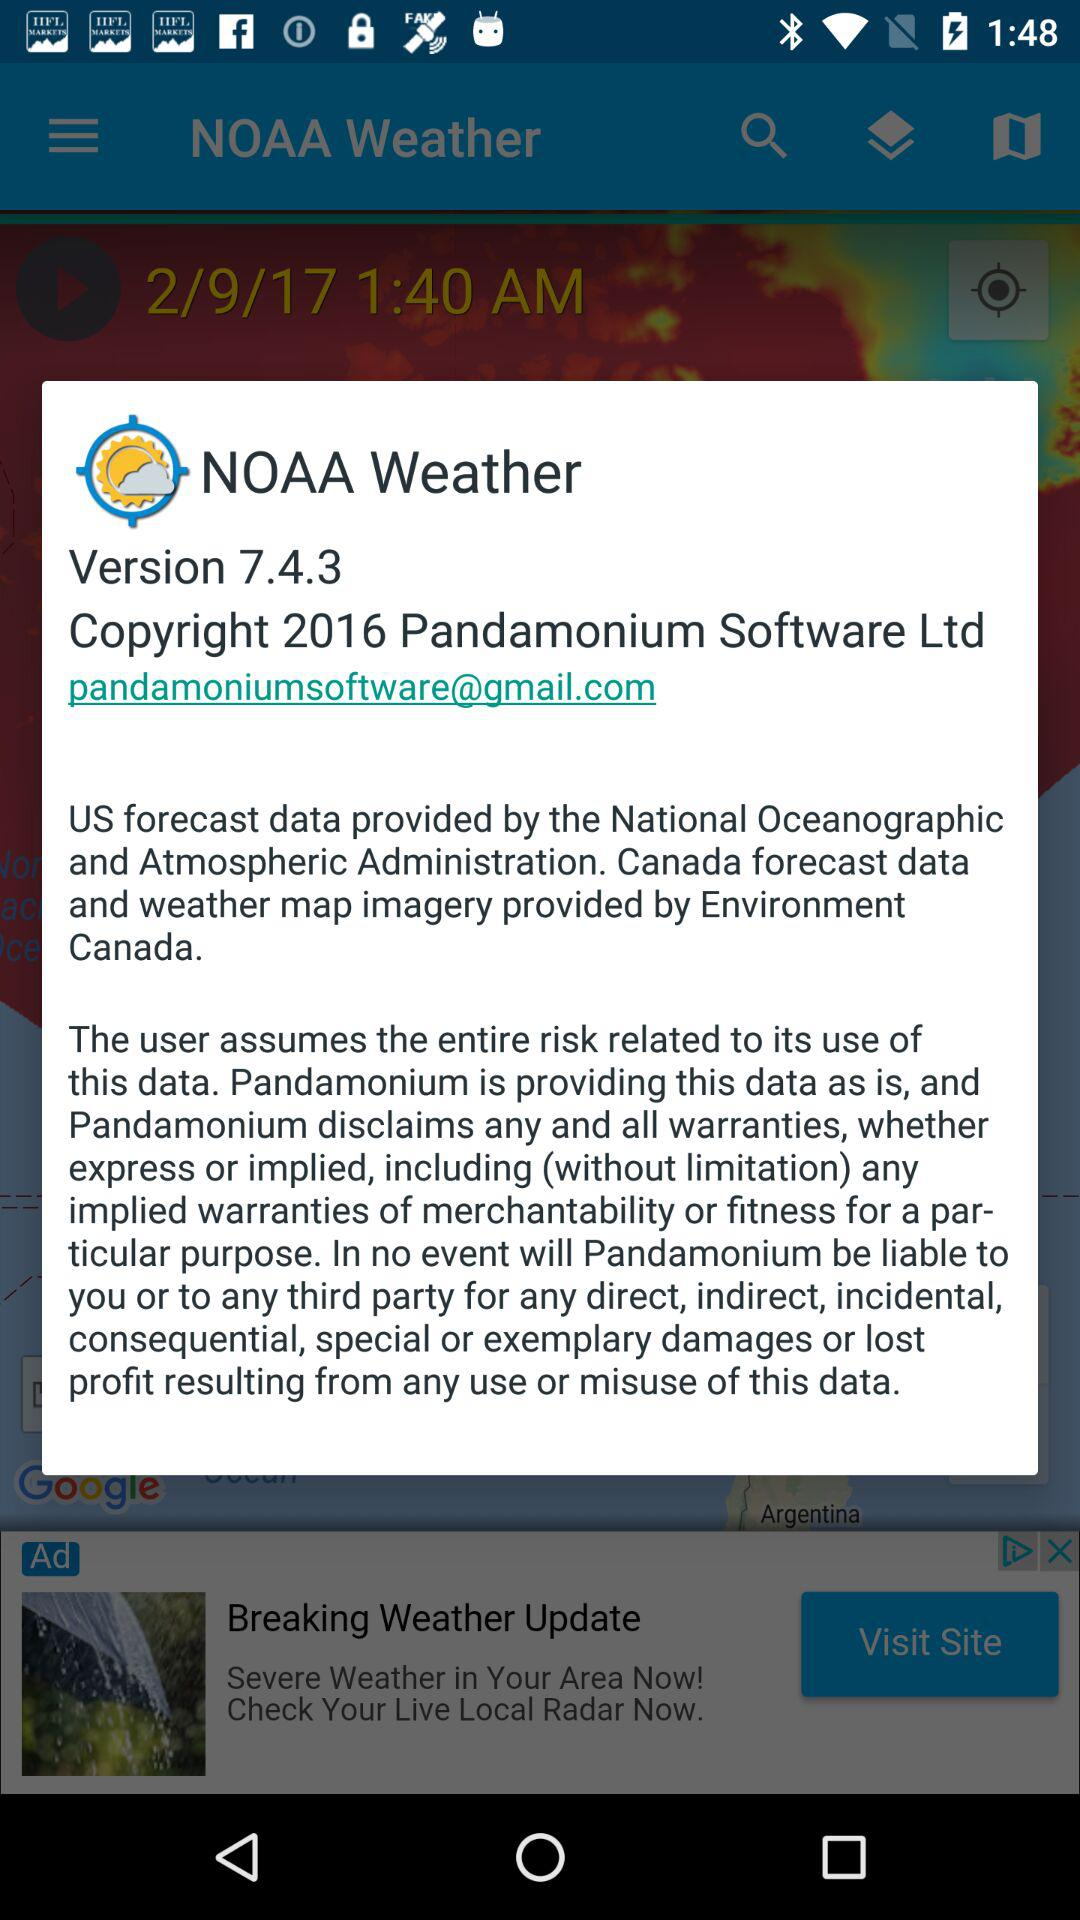What is the version of "NOAA weather"? The version is 7.4.3. 